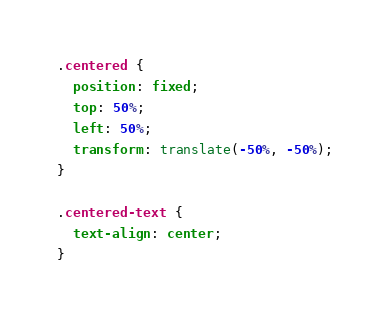<code> <loc_0><loc_0><loc_500><loc_500><_CSS_>.centered {
  position: fixed;
  top: 50%;
  left: 50%;
  transform: translate(-50%, -50%);
}

.centered-text {
  text-align: center;
}
</code> 